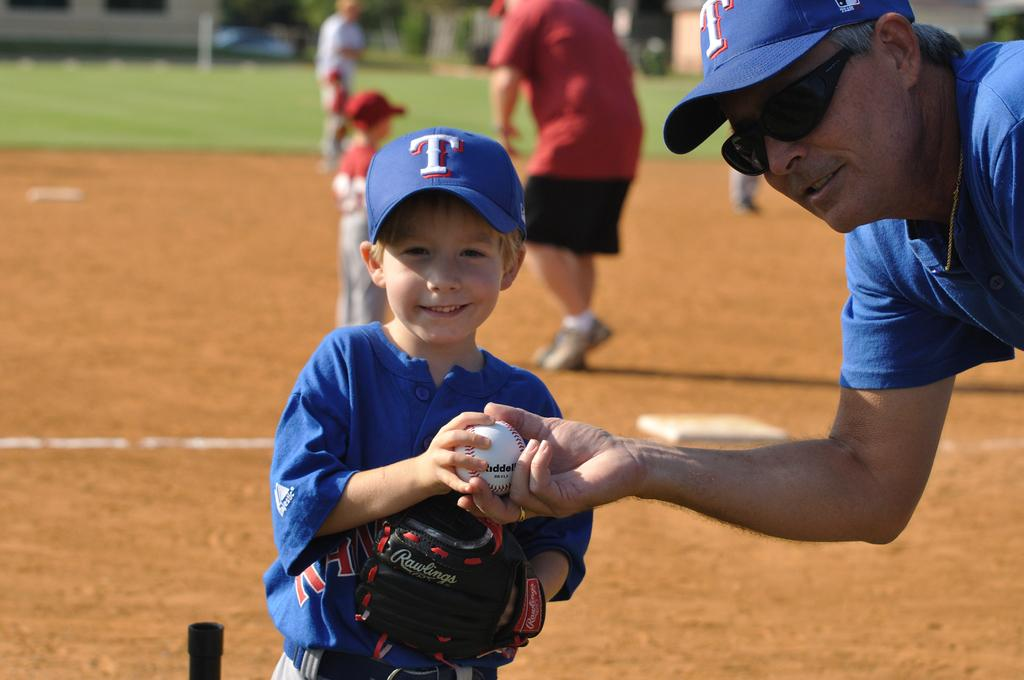<image>
Create a compact narrative representing the image presented. a boy and man holding a baseball and wearing T hats 